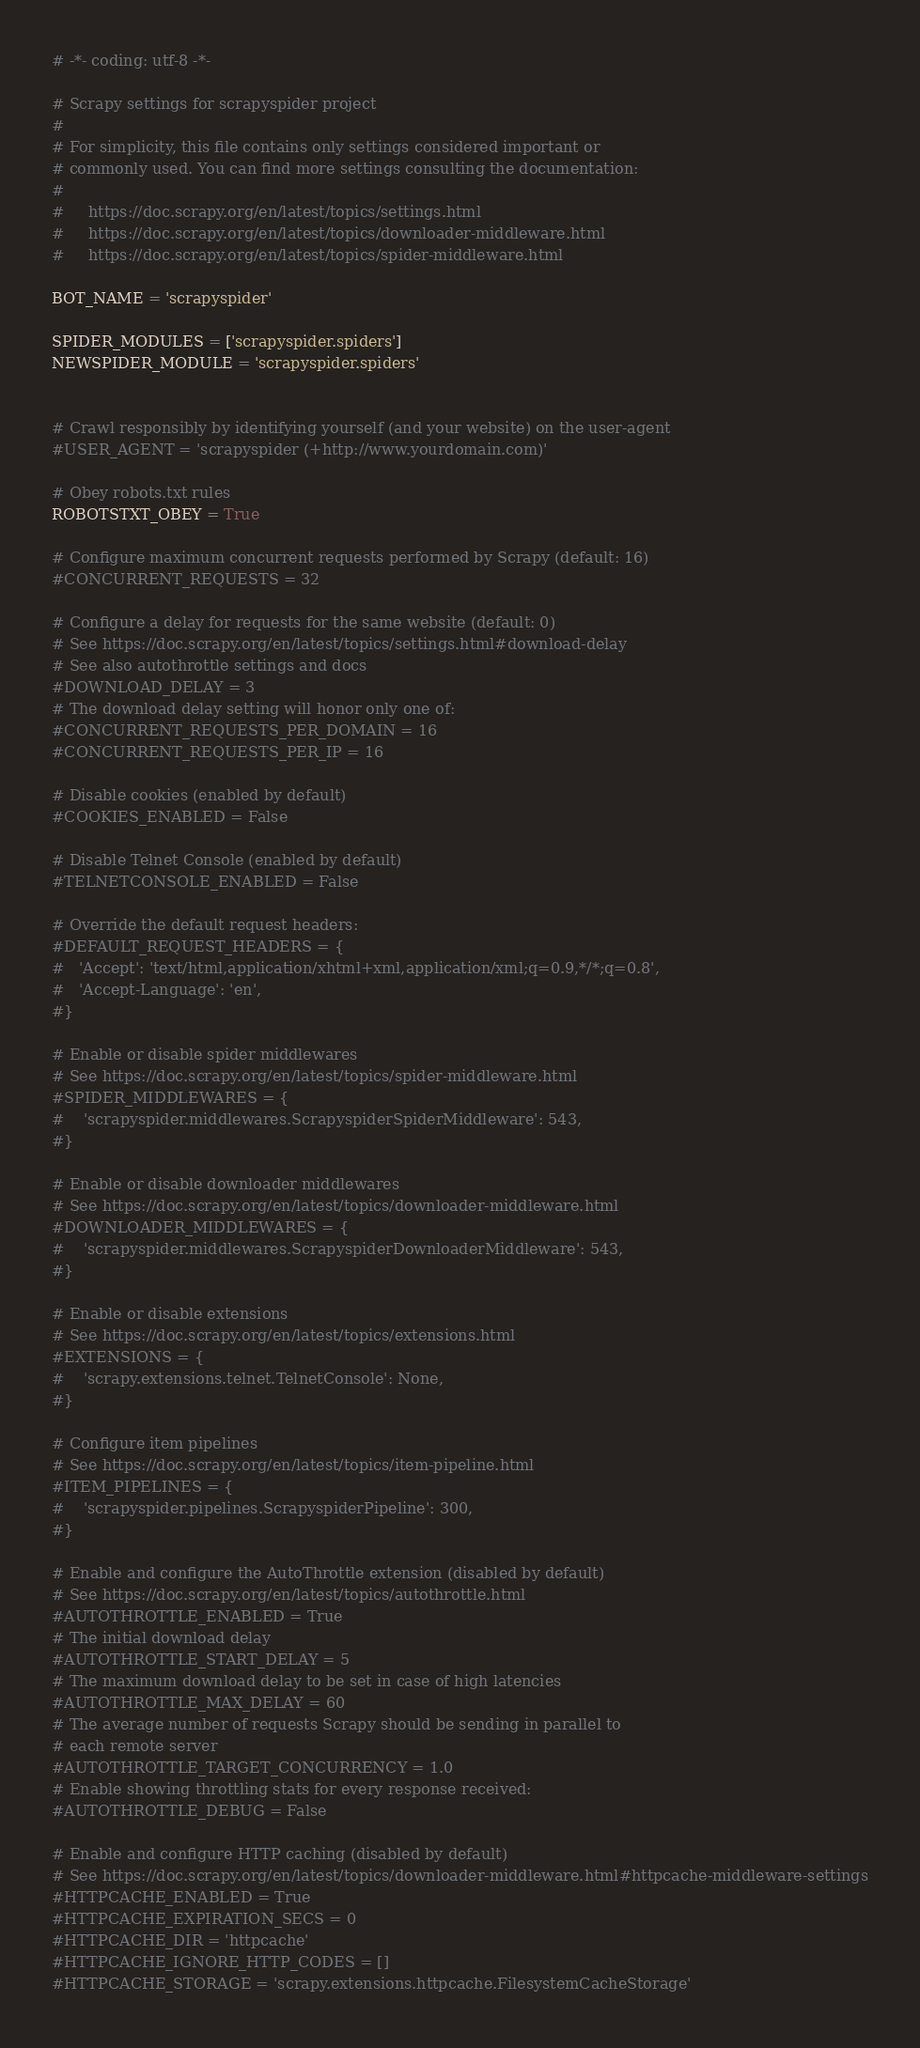Convert code to text. <code><loc_0><loc_0><loc_500><loc_500><_Python_># -*- coding: utf-8 -*-

# Scrapy settings for scrapyspider project
#
# For simplicity, this file contains only settings considered important or
# commonly used. You can find more settings consulting the documentation:
#
#     https://doc.scrapy.org/en/latest/topics/settings.html
#     https://doc.scrapy.org/en/latest/topics/downloader-middleware.html
#     https://doc.scrapy.org/en/latest/topics/spider-middleware.html

BOT_NAME = 'scrapyspider'

SPIDER_MODULES = ['scrapyspider.spiders']
NEWSPIDER_MODULE = 'scrapyspider.spiders'


# Crawl responsibly by identifying yourself (and your website) on the user-agent
#USER_AGENT = 'scrapyspider (+http://www.yourdomain.com)'

# Obey robots.txt rules
ROBOTSTXT_OBEY = True

# Configure maximum concurrent requests performed by Scrapy (default: 16)
#CONCURRENT_REQUESTS = 32

# Configure a delay for requests for the same website (default: 0)
# See https://doc.scrapy.org/en/latest/topics/settings.html#download-delay
# See also autothrottle settings and docs
#DOWNLOAD_DELAY = 3
# The download delay setting will honor only one of:
#CONCURRENT_REQUESTS_PER_DOMAIN = 16
#CONCURRENT_REQUESTS_PER_IP = 16

# Disable cookies (enabled by default)
#COOKIES_ENABLED = False

# Disable Telnet Console (enabled by default)
#TELNETCONSOLE_ENABLED = False

# Override the default request headers:
#DEFAULT_REQUEST_HEADERS = {
#   'Accept': 'text/html,application/xhtml+xml,application/xml;q=0.9,*/*;q=0.8',
#   'Accept-Language': 'en',
#}

# Enable or disable spider middlewares
# See https://doc.scrapy.org/en/latest/topics/spider-middleware.html
#SPIDER_MIDDLEWARES = {
#    'scrapyspider.middlewares.ScrapyspiderSpiderMiddleware': 543,
#}

# Enable or disable downloader middlewares
# See https://doc.scrapy.org/en/latest/topics/downloader-middleware.html
#DOWNLOADER_MIDDLEWARES = {
#    'scrapyspider.middlewares.ScrapyspiderDownloaderMiddleware': 543,
#}

# Enable or disable extensions
# See https://doc.scrapy.org/en/latest/topics/extensions.html
#EXTENSIONS = {
#    'scrapy.extensions.telnet.TelnetConsole': None,
#}

# Configure item pipelines
# See https://doc.scrapy.org/en/latest/topics/item-pipeline.html
#ITEM_PIPELINES = {
#    'scrapyspider.pipelines.ScrapyspiderPipeline': 300,
#}

# Enable and configure the AutoThrottle extension (disabled by default)
# See https://doc.scrapy.org/en/latest/topics/autothrottle.html
#AUTOTHROTTLE_ENABLED = True
# The initial download delay
#AUTOTHROTTLE_START_DELAY = 5
# The maximum download delay to be set in case of high latencies
#AUTOTHROTTLE_MAX_DELAY = 60
# The average number of requests Scrapy should be sending in parallel to
# each remote server
#AUTOTHROTTLE_TARGET_CONCURRENCY = 1.0
# Enable showing throttling stats for every response received:
#AUTOTHROTTLE_DEBUG = False

# Enable and configure HTTP caching (disabled by default)
# See https://doc.scrapy.org/en/latest/topics/downloader-middleware.html#httpcache-middleware-settings
#HTTPCACHE_ENABLED = True
#HTTPCACHE_EXPIRATION_SECS = 0
#HTTPCACHE_DIR = 'httpcache'
#HTTPCACHE_IGNORE_HTTP_CODES = []
#HTTPCACHE_STORAGE = 'scrapy.extensions.httpcache.FilesystemCacheStorage'
</code> 